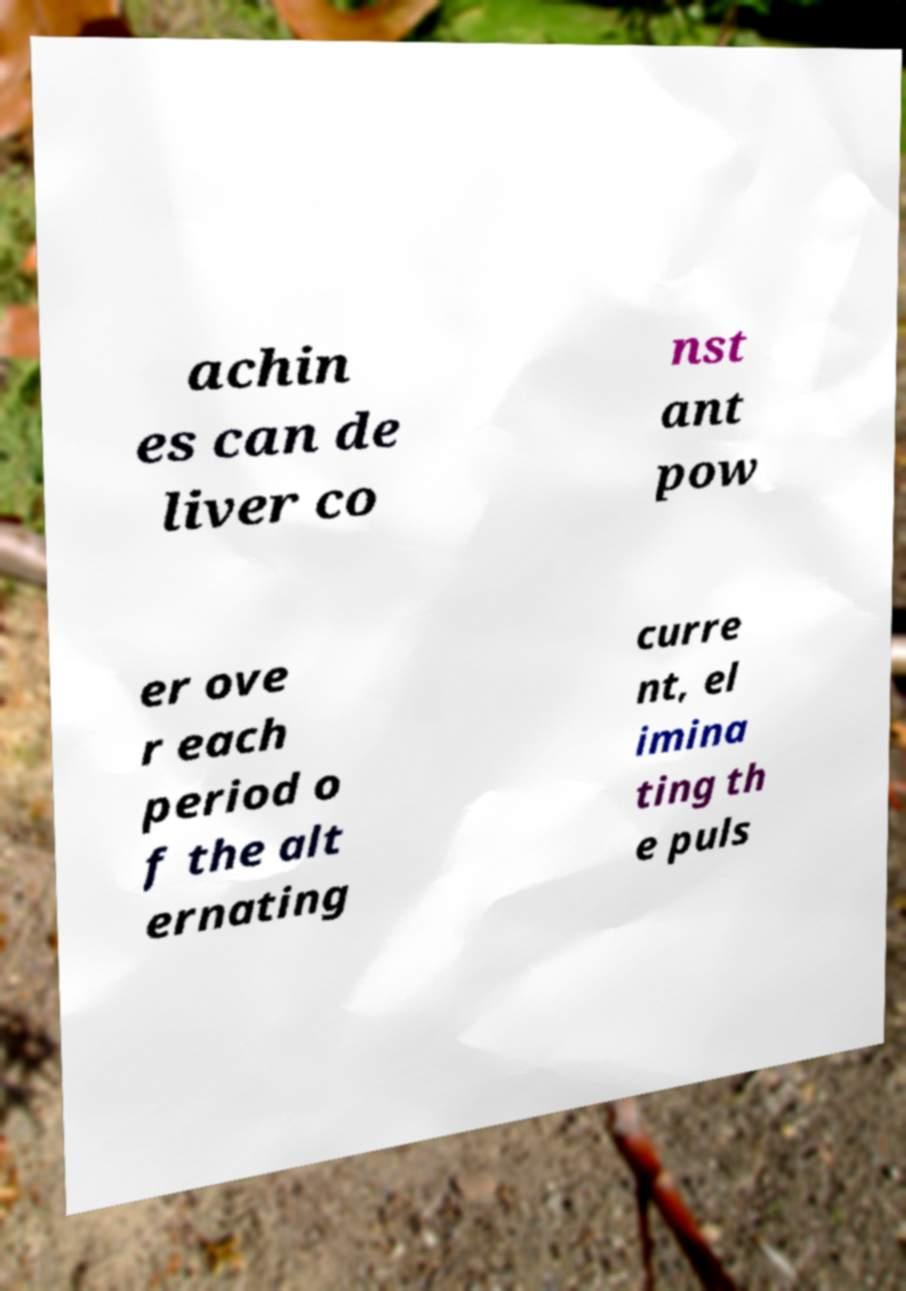For documentation purposes, I need the text within this image transcribed. Could you provide that? achin es can de liver co nst ant pow er ove r each period o f the alt ernating curre nt, el imina ting th e puls 